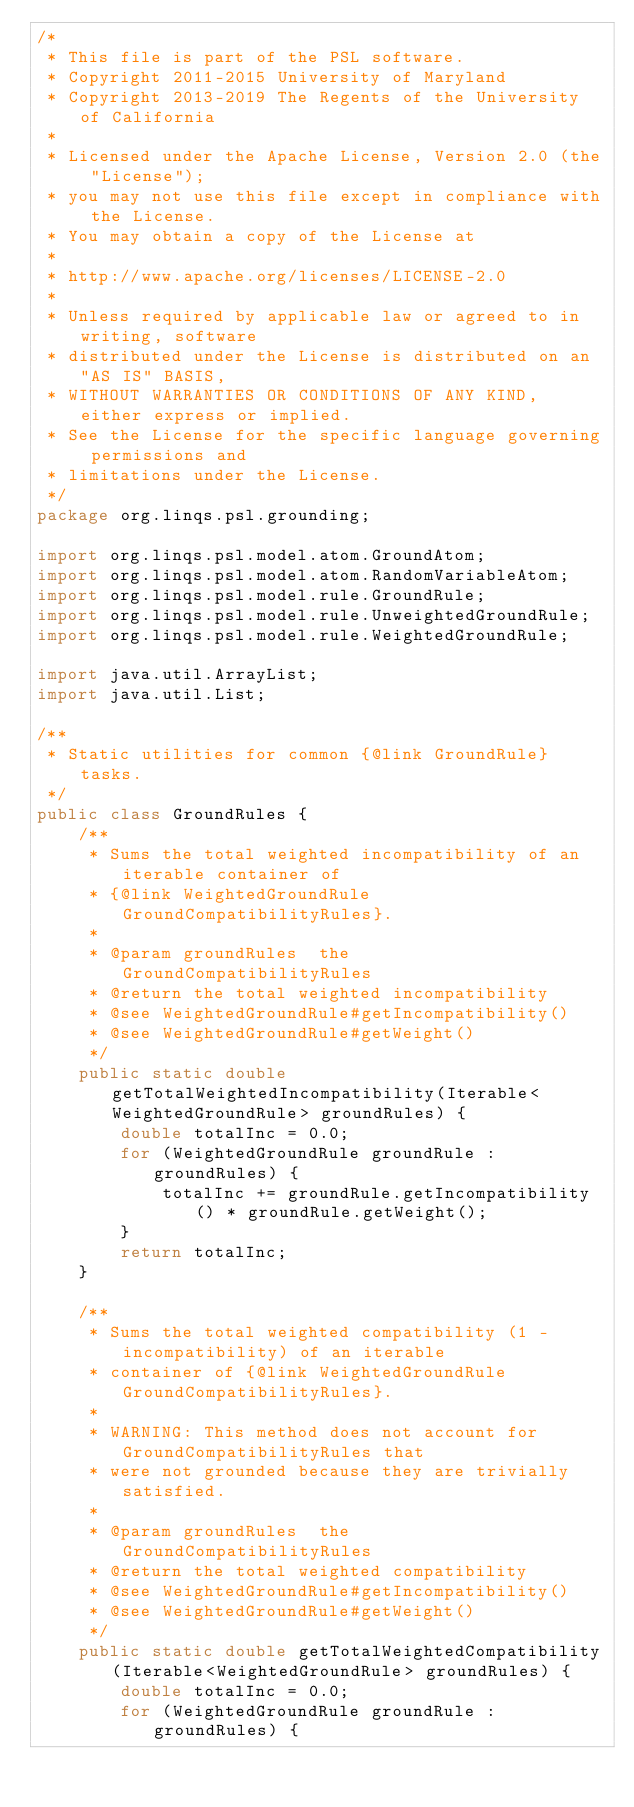Convert code to text. <code><loc_0><loc_0><loc_500><loc_500><_Java_>/*
 * This file is part of the PSL software.
 * Copyright 2011-2015 University of Maryland
 * Copyright 2013-2019 The Regents of the University of California
 *
 * Licensed under the Apache License, Version 2.0 (the "License");
 * you may not use this file except in compliance with the License.
 * You may obtain a copy of the License at
 *
 * http://www.apache.org/licenses/LICENSE-2.0
 *
 * Unless required by applicable law or agreed to in writing, software
 * distributed under the License is distributed on an "AS IS" BASIS,
 * WITHOUT WARRANTIES OR CONDITIONS OF ANY KIND, either express or implied.
 * See the License for the specific language governing permissions and
 * limitations under the License.
 */
package org.linqs.psl.grounding;

import org.linqs.psl.model.atom.GroundAtom;
import org.linqs.psl.model.atom.RandomVariableAtom;
import org.linqs.psl.model.rule.GroundRule;
import org.linqs.psl.model.rule.UnweightedGroundRule;
import org.linqs.psl.model.rule.WeightedGroundRule;

import java.util.ArrayList;
import java.util.List;

/**
 * Static utilities for common {@link GroundRule} tasks.
 */
public class GroundRules {
    /**
     * Sums the total weighted incompatibility of an iterable container of
     * {@link WeightedGroundRule GroundCompatibilityRules}.
     *
     * @param groundRules  the GroundCompatibilityRules
     * @return the total weighted incompatibility
     * @see WeightedGroundRule#getIncompatibility()
     * @see WeightedGroundRule#getWeight()
     */
    public static double getTotalWeightedIncompatibility(Iterable<WeightedGroundRule> groundRules) {
        double totalInc = 0.0;
        for (WeightedGroundRule groundRule : groundRules) {
            totalInc += groundRule.getIncompatibility() * groundRule.getWeight();
        }
        return totalInc;
    }

    /**
     * Sums the total weighted compatibility (1 - incompatibility) of an iterable
     * container of {@link WeightedGroundRule GroundCompatibilityRules}.
     *
     * WARNING: This method does not account for GroundCompatibilityRules that
     * were not grounded because they are trivially satisfied.
     *
     * @param groundRules  the GroundCompatibilityRules
     * @return the total weighted compatibility
     * @see WeightedGroundRule#getIncompatibility()
     * @see WeightedGroundRule#getWeight()
     */
    public static double getTotalWeightedCompatibility(Iterable<WeightedGroundRule> groundRules) {
        double totalInc = 0.0;
        for (WeightedGroundRule groundRule : groundRules) {</code> 